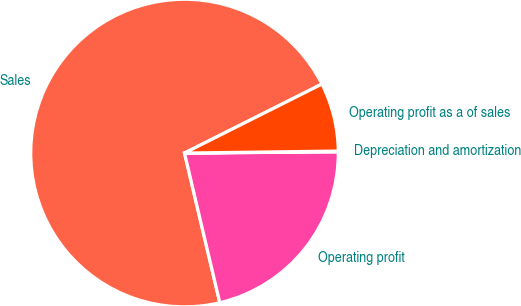Convert chart. <chart><loc_0><loc_0><loc_500><loc_500><pie_chart><fcel>Sales<fcel>Operating profit<fcel>Depreciation and amortization<fcel>Operating profit as a of sales<nl><fcel>71.28%<fcel>21.44%<fcel>0.08%<fcel>7.2%<nl></chart> 